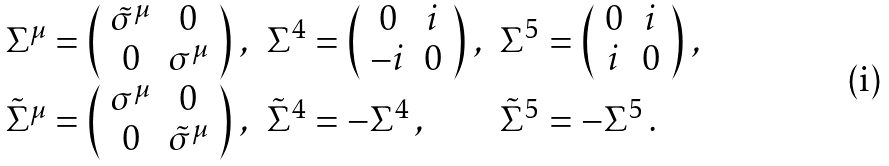Convert formula to latex. <formula><loc_0><loc_0><loc_500><loc_500>\begin{array} { c l l } \Sigma ^ { \mu } = \left ( \begin{array} { c c } \tilde { \sigma } ^ { \mu } & 0 \\ 0 & \sigma ^ { \mu } \end{array} \right ) \, , & \Sigma ^ { 4 } = \left ( \begin{array} { c c } 0 & i \\ - i & 0 \end{array} \right ) \, , & \Sigma ^ { 5 } = \left ( \begin{array} { c c } 0 & i \\ i & 0 \end{array} \right ) \, , \\ \tilde { \Sigma } ^ { \mu } = \left ( \begin{array} { c c } \sigma ^ { \mu } & 0 \\ 0 & \tilde { \sigma } ^ { \mu } \end{array} \right ) \, , & \tilde { \Sigma } ^ { 4 } = - \Sigma ^ { 4 } \, , & \tilde { \Sigma } ^ { 5 } = - \Sigma ^ { 5 } \, . \end{array}</formula> 